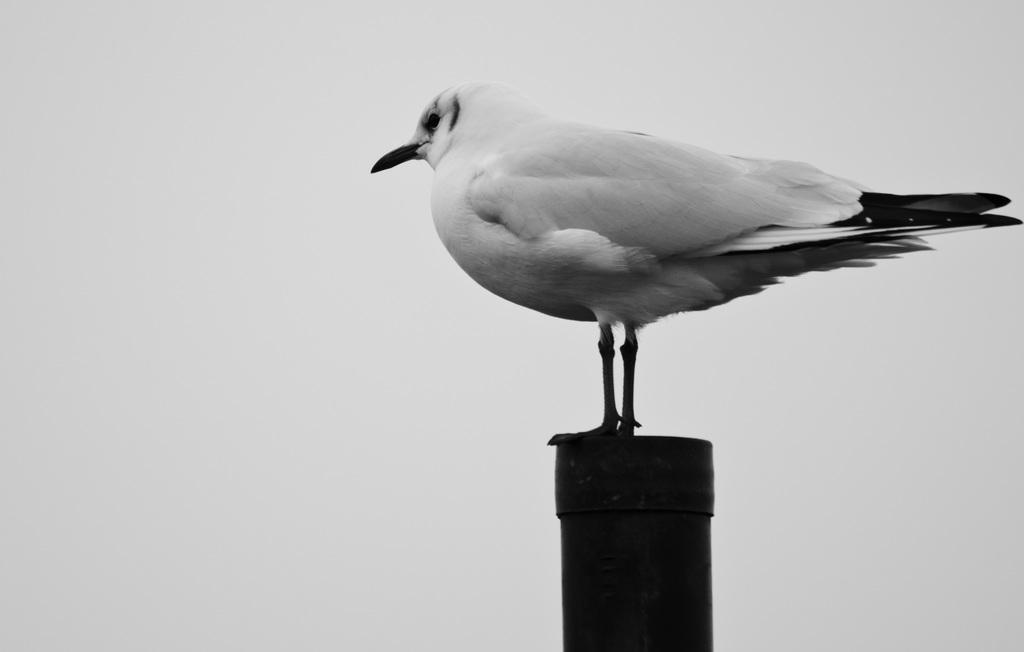In one or two sentences, can you explain what this image depicts? In this picture we can see a dove is standing, at the bottom it looks like a pipe, there is a plane background, it is a black and white image. 